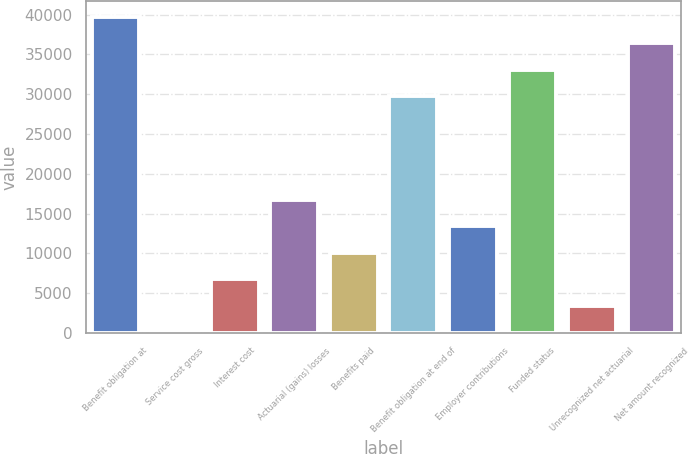Convert chart to OTSL. <chart><loc_0><loc_0><loc_500><loc_500><bar_chart><fcel>Benefit obligation at<fcel>Service cost gross<fcel>Interest cost<fcel>Actuarial (gains) losses<fcel>Benefits paid<fcel>Benefit obligation at end of<fcel>Employer contributions<fcel>Funded status<fcel>Unrecognized net actuarial<fcel>Net amount recognized<nl><fcel>39729.3<fcel>132<fcel>6766.2<fcel>16717.5<fcel>10083.3<fcel>29778<fcel>13400.4<fcel>33095.1<fcel>3449.1<fcel>36412.2<nl></chart> 